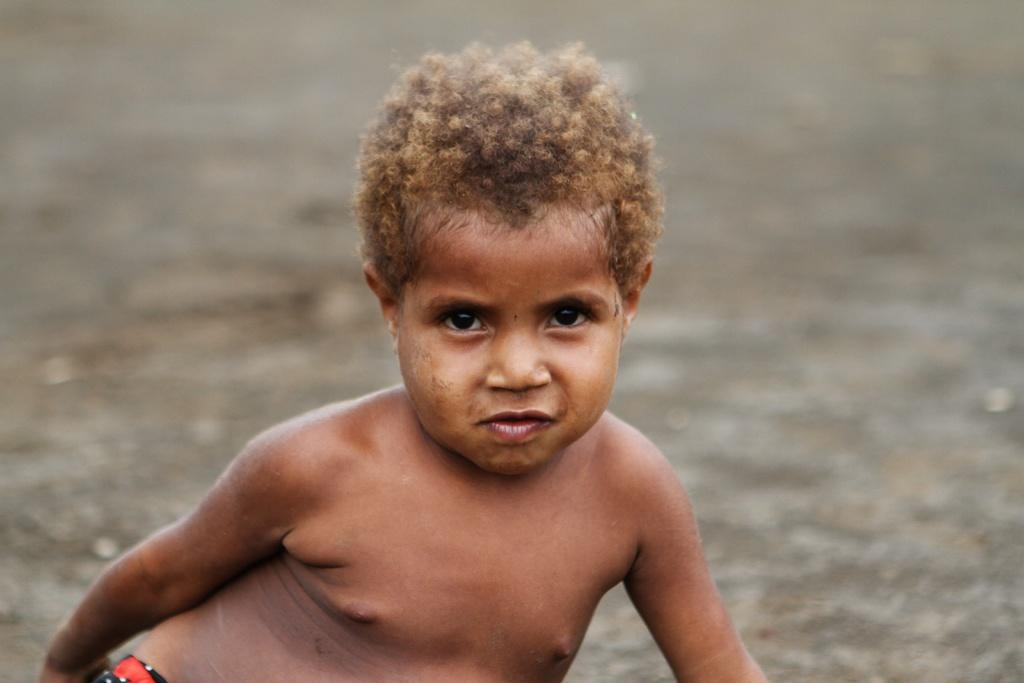What is the main subject of the image? The main subject of the image is a kid. Can you describe the background of the image? The background of the image is white. Can you tell me how the pig is using friction to walk in the image? There is no pig present in the image, and therefore no such activity can be observed. 